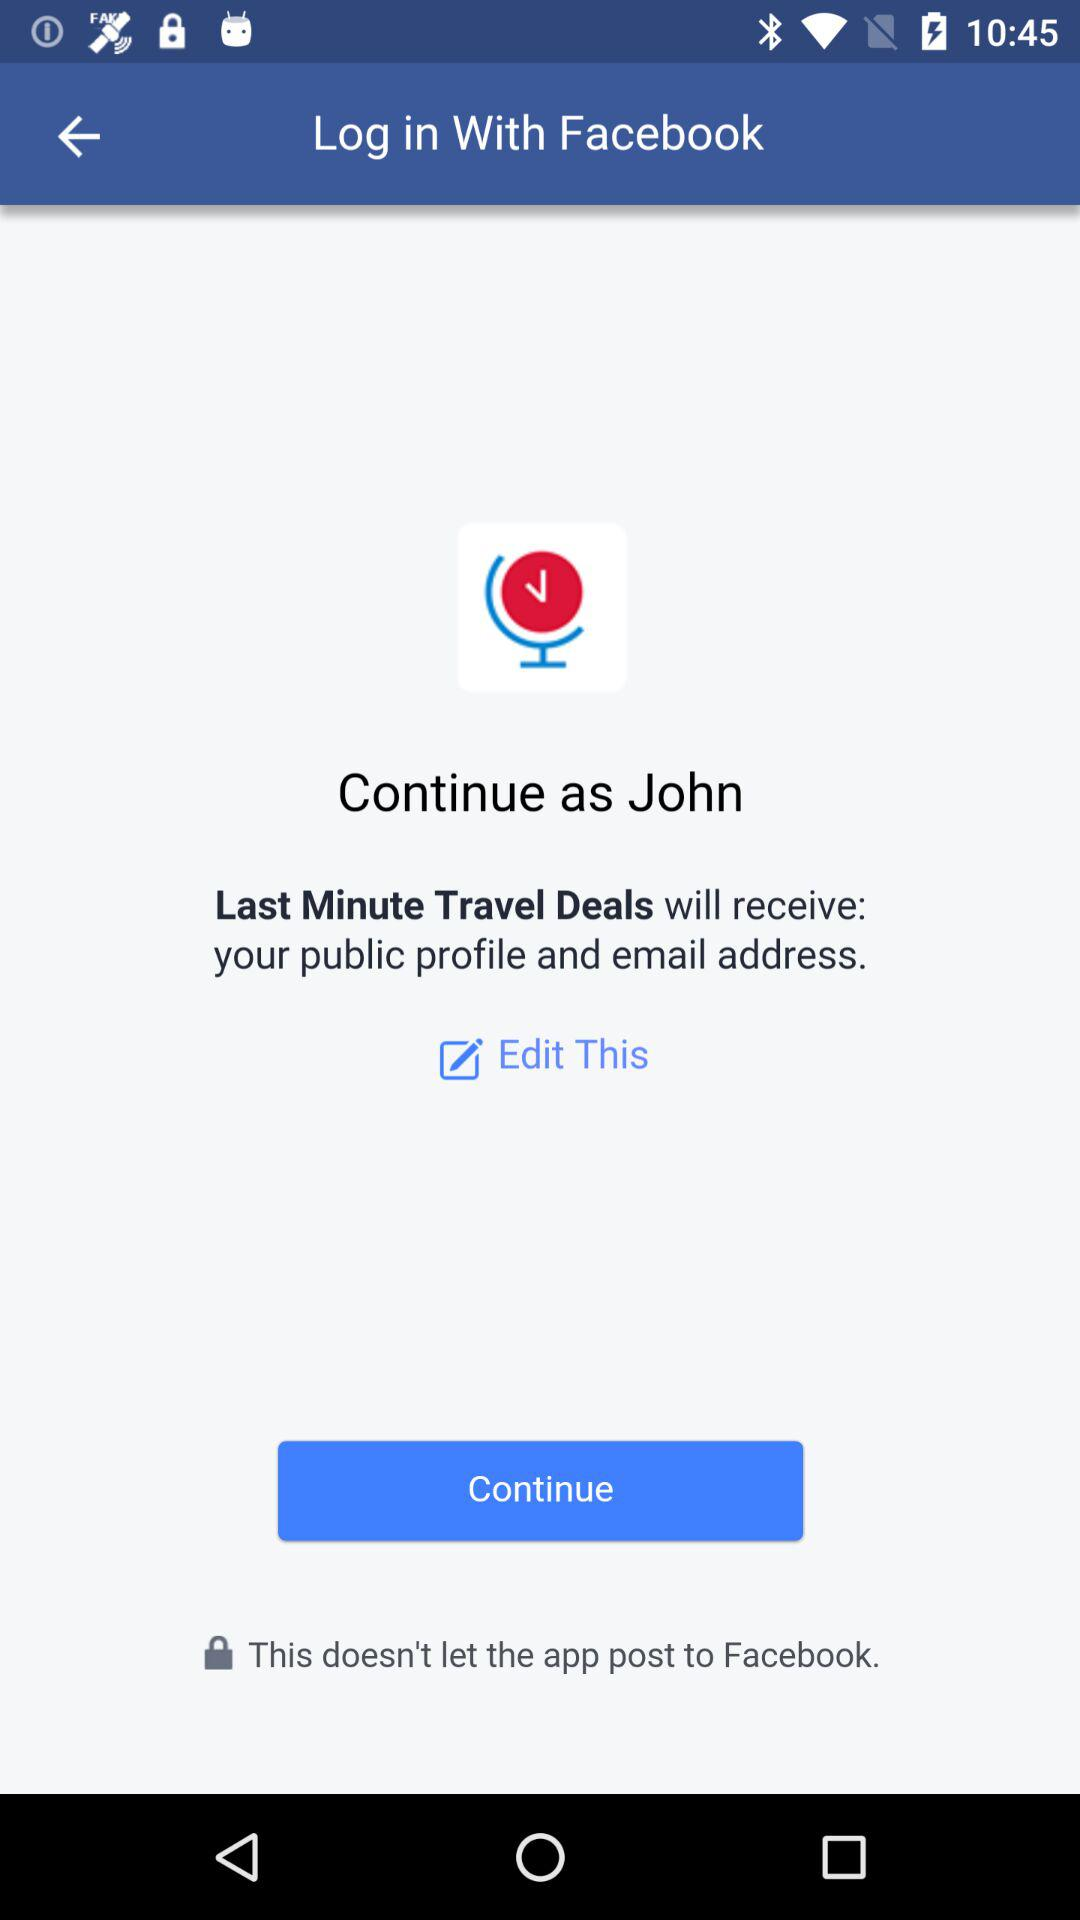What application is asking for permission? The application asking for permission is "Last Minute Travel Deals". 